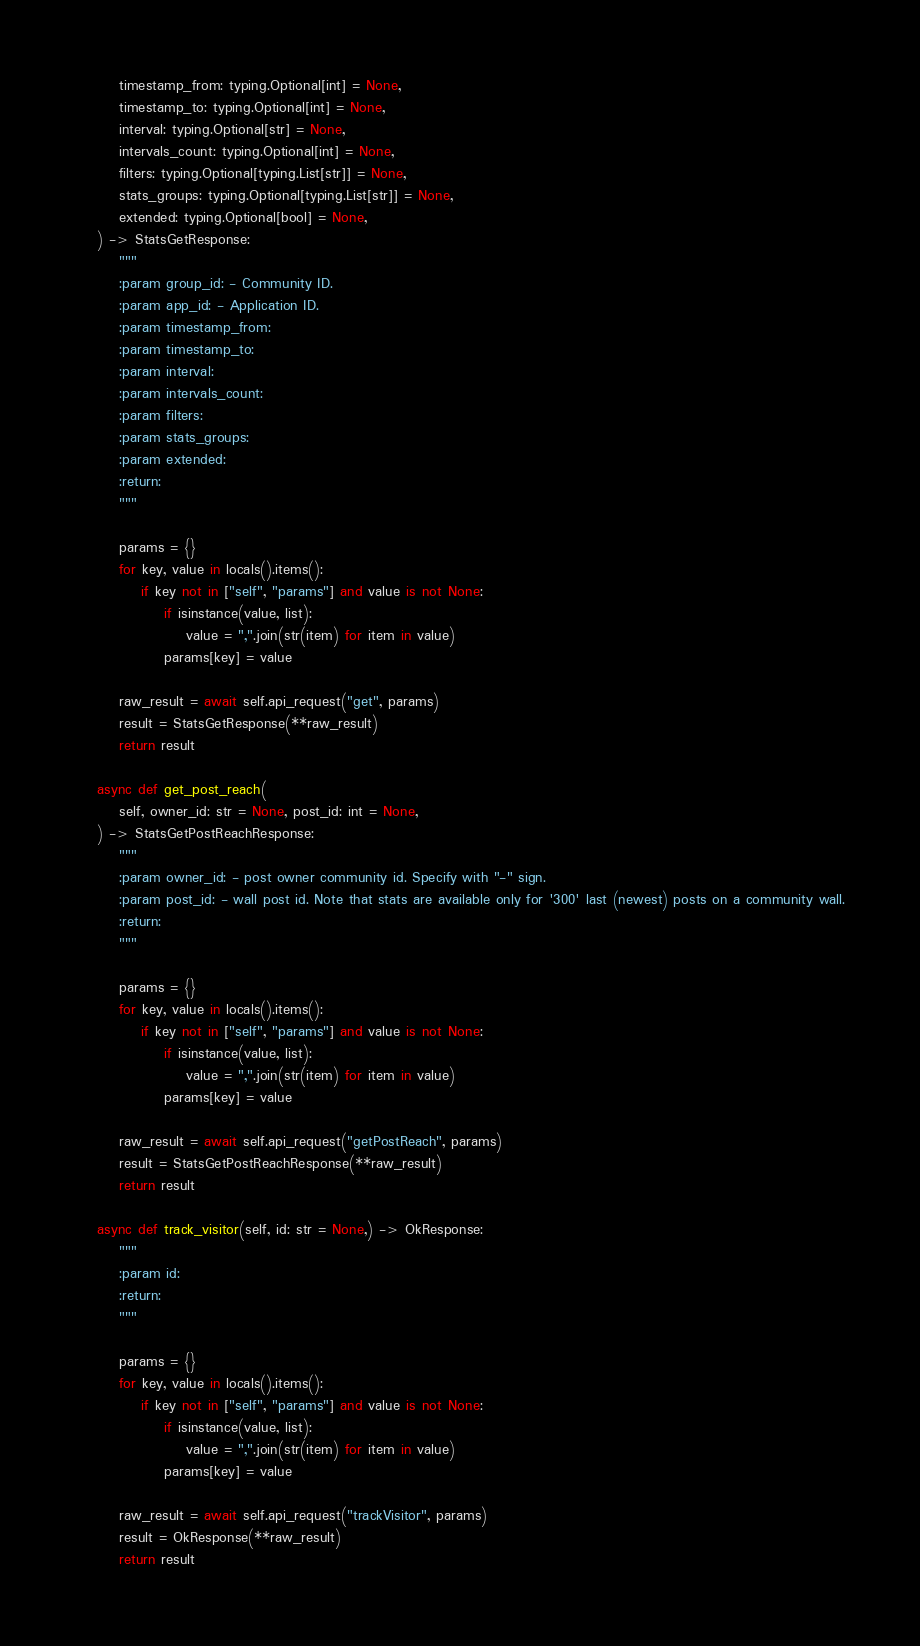<code> <loc_0><loc_0><loc_500><loc_500><_Python_>        timestamp_from: typing.Optional[int] = None,
        timestamp_to: typing.Optional[int] = None,
        interval: typing.Optional[str] = None,
        intervals_count: typing.Optional[int] = None,
        filters: typing.Optional[typing.List[str]] = None,
        stats_groups: typing.Optional[typing.List[str]] = None,
        extended: typing.Optional[bool] = None,
    ) -> StatsGetResponse:
        """
        :param group_id: - Community ID.
        :param app_id: - Application ID.
        :param timestamp_from:
        :param timestamp_to:
        :param interval:
        :param intervals_count:
        :param filters:
        :param stats_groups:
        :param extended:
        :return:
        """

        params = {}
        for key, value in locals().items():
            if key not in ["self", "params"] and value is not None:
                if isinstance(value, list):
                    value = ",".join(str(item) for item in value)
                params[key] = value

        raw_result = await self.api_request("get", params)
        result = StatsGetResponse(**raw_result)
        return result

    async def get_post_reach(
        self, owner_id: str = None, post_id: int = None,
    ) -> StatsGetPostReachResponse:
        """
        :param owner_id: - post owner community id. Specify with "-" sign.
        :param post_id: - wall post id. Note that stats are available only for '300' last (newest) posts on a community wall.
        :return:
        """

        params = {}
        for key, value in locals().items():
            if key not in ["self", "params"] and value is not None:
                if isinstance(value, list):
                    value = ",".join(str(item) for item in value)
                params[key] = value

        raw_result = await self.api_request("getPostReach", params)
        result = StatsGetPostReachResponse(**raw_result)
        return result

    async def track_visitor(self, id: str = None,) -> OkResponse:
        """
        :param id:
        :return:
        """

        params = {}
        for key, value in locals().items():
            if key not in ["self", "params"] and value is not None:
                if isinstance(value, list):
                    value = ",".join(str(item) for item in value)
                params[key] = value

        raw_result = await self.api_request("trackVisitor", params)
        result = OkResponse(**raw_result)
        return result
</code> 